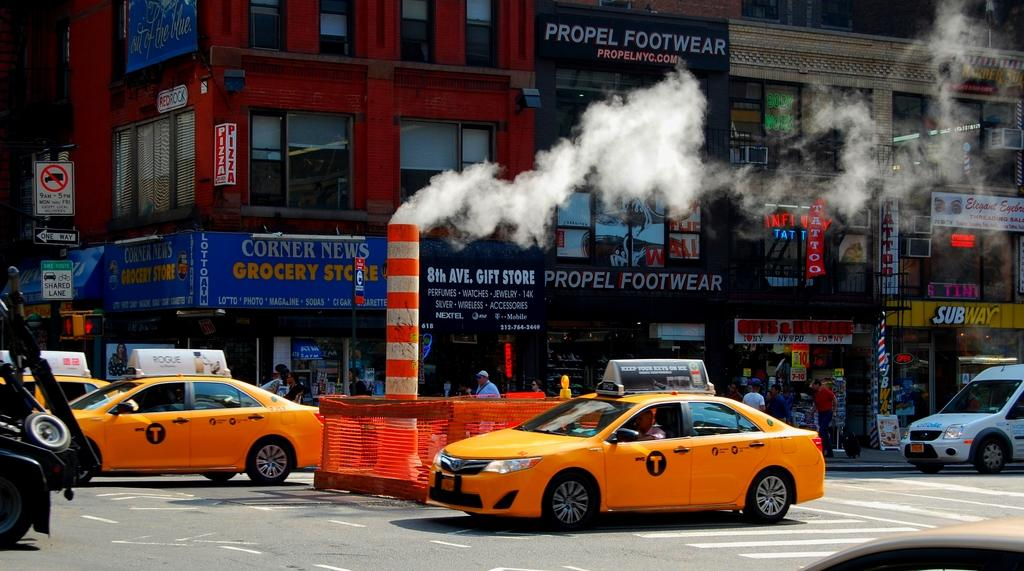<image>
Summarize the visual content of the image. a car with the letter T on the side 